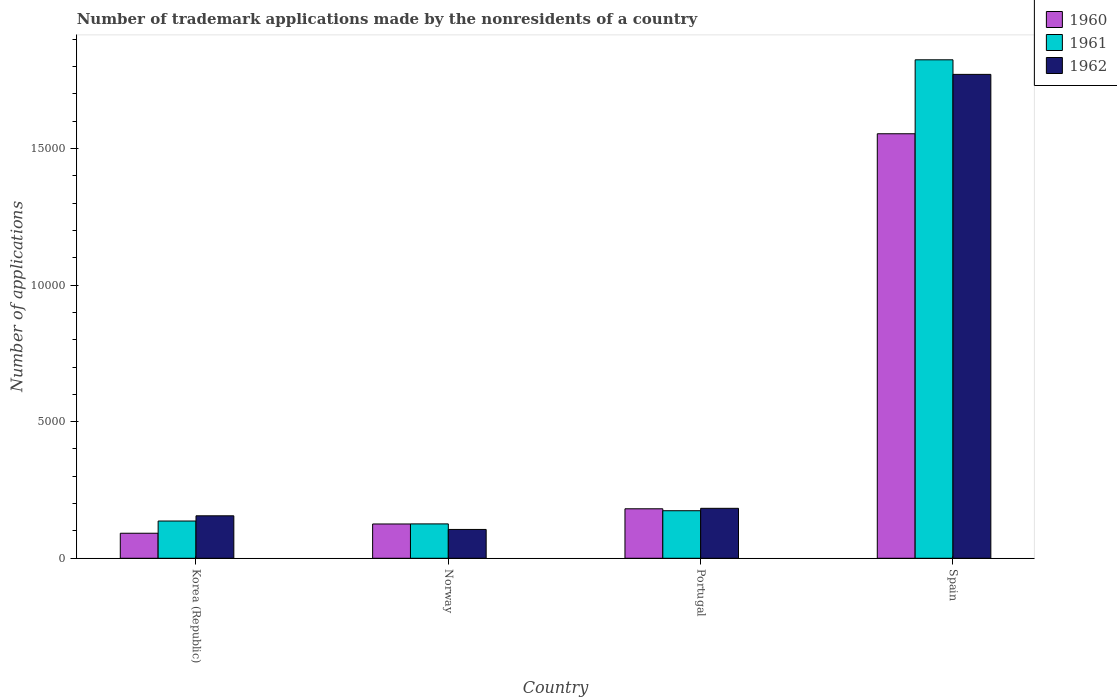How many different coloured bars are there?
Make the answer very short. 3. Are the number of bars per tick equal to the number of legend labels?
Ensure brevity in your answer.  Yes. In how many cases, is the number of bars for a given country not equal to the number of legend labels?
Provide a succinct answer. 0. What is the number of trademark applications made by the nonresidents in 1961 in Spain?
Your answer should be compact. 1.82e+04. Across all countries, what is the maximum number of trademark applications made by the nonresidents in 1960?
Your response must be concise. 1.55e+04. Across all countries, what is the minimum number of trademark applications made by the nonresidents in 1962?
Provide a short and direct response. 1055. In which country was the number of trademark applications made by the nonresidents in 1961 maximum?
Give a very brief answer. Spain. What is the total number of trademark applications made by the nonresidents in 1962 in the graph?
Your response must be concise. 2.21e+04. What is the difference between the number of trademark applications made by the nonresidents in 1962 in Korea (Republic) and that in Norway?
Ensure brevity in your answer.  499. What is the difference between the number of trademark applications made by the nonresidents in 1960 in Portugal and the number of trademark applications made by the nonresidents in 1962 in Norway?
Offer a terse response. 756. What is the average number of trademark applications made by the nonresidents in 1962 per country?
Your answer should be very brief. 5536.75. What is the difference between the number of trademark applications made by the nonresidents of/in 1961 and number of trademark applications made by the nonresidents of/in 1960 in Korea (Republic)?
Keep it short and to the point. 447. What is the ratio of the number of trademark applications made by the nonresidents in 1960 in Korea (Republic) to that in Portugal?
Make the answer very short. 0.51. Is the number of trademark applications made by the nonresidents in 1961 in Norway less than that in Portugal?
Provide a succinct answer. Yes. Is the difference between the number of trademark applications made by the nonresidents in 1961 in Portugal and Spain greater than the difference between the number of trademark applications made by the nonresidents in 1960 in Portugal and Spain?
Offer a terse response. No. What is the difference between the highest and the second highest number of trademark applications made by the nonresidents in 1961?
Your answer should be compact. -377. What is the difference between the highest and the lowest number of trademark applications made by the nonresidents in 1962?
Provide a succinct answer. 1.67e+04. What does the 3rd bar from the left in Spain represents?
Ensure brevity in your answer.  1962. Is it the case that in every country, the sum of the number of trademark applications made by the nonresidents in 1960 and number of trademark applications made by the nonresidents in 1962 is greater than the number of trademark applications made by the nonresidents in 1961?
Keep it short and to the point. Yes. How many bars are there?
Make the answer very short. 12. Are all the bars in the graph horizontal?
Ensure brevity in your answer.  No. What is the difference between two consecutive major ticks on the Y-axis?
Your answer should be very brief. 5000. Does the graph contain any zero values?
Ensure brevity in your answer.  No. Does the graph contain grids?
Make the answer very short. No. Where does the legend appear in the graph?
Keep it short and to the point. Top right. How many legend labels are there?
Offer a terse response. 3. What is the title of the graph?
Provide a succinct answer. Number of trademark applications made by the nonresidents of a country. What is the label or title of the Y-axis?
Offer a terse response. Number of applications. What is the Number of applications of 1960 in Korea (Republic)?
Provide a succinct answer. 916. What is the Number of applications in 1961 in Korea (Republic)?
Give a very brief answer. 1363. What is the Number of applications of 1962 in Korea (Republic)?
Your answer should be very brief. 1554. What is the Number of applications of 1960 in Norway?
Your answer should be very brief. 1255. What is the Number of applications in 1961 in Norway?
Ensure brevity in your answer.  1258. What is the Number of applications in 1962 in Norway?
Ensure brevity in your answer.  1055. What is the Number of applications in 1960 in Portugal?
Provide a short and direct response. 1811. What is the Number of applications of 1961 in Portugal?
Make the answer very short. 1740. What is the Number of applications in 1962 in Portugal?
Provide a short and direct response. 1828. What is the Number of applications of 1960 in Spain?
Ensure brevity in your answer.  1.55e+04. What is the Number of applications of 1961 in Spain?
Your answer should be very brief. 1.82e+04. What is the Number of applications of 1962 in Spain?
Your answer should be very brief. 1.77e+04. Across all countries, what is the maximum Number of applications in 1960?
Give a very brief answer. 1.55e+04. Across all countries, what is the maximum Number of applications of 1961?
Your answer should be very brief. 1.82e+04. Across all countries, what is the maximum Number of applications of 1962?
Your answer should be compact. 1.77e+04. Across all countries, what is the minimum Number of applications of 1960?
Ensure brevity in your answer.  916. Across all countries, what is the minimum Number of applications of 1961?
Your answer should be compact. 1258. Across all countries, what is the minimum Number of applications of 1962?
Your answer should be very brief. 1055. What is the total Number of applications of 1960 in the graph?
Keep it short and to the point. 1.95e+04. What is the total Number of applications of 1961 in the graph?
Offer a terse response. 2.26e+04. What is the total Number of applications in 1962 in the graph?
Ensure brevity in your answer.  2.21e+04. What is the difference between the Number of applications of 1960 in Korea (Republic) and that in Norway?
Offer a very short reply. -339. What is the difference between the Number of applications of 1961 in Korea (Republic) and that in Norway?
Give a very brief answer. 105. What is the difference between the Number of applications of 1962 in Korea (Republic) and that in Norway?
Ensure brevity in your answer.  499. What is the difference between the Number of applications in 1960 in Korea (Republic) and that in Portugal?
Provide a succinct answer. -895. What is the difference between the Number of applications of 1961 in Korea (Republic) and that in Portugal?
Offer a terse response. -377. What is the difference between the Number of applications of 1962 in Korea (Republic) and that in Portugal?
Your response must be concise. -274. What is the difference between the Number of applications of 1960 in Korea (Republic) and that in Spain?
Your answer should be very brief. -1.46e+04. What is the difference between the Number of applications of 1961 in Korea (Republic) and that in Spain?
Make the answer very short. -1.69e+04. What is the difference between the Number of applications in 1962 in Korea (Republic) and that in Spain?
Keep it short and to the point. -1.62e+04. What is the difference between the Number of applications in 1960 in Norway and that in Portugal?
Provide a short and direct response. -556. What is the difference between the Number of applications of 1961 in Norway and that in Portugal?
Offer a very short reply. -482. What is the difference between the Number of applications in 1962 in Norway and that in Portugal?
Provide a succinct answer. -773. What is the difference between the Number of applications in 1960 in Norway and that in Spain?
Provide a short and direct response. -1.43e+04. What is the difference between the Number of applications in 1961 in Norway and that in Spain?
Your answer should be compact. -1.70e+04. What is the difference between the Number of applications in 1962 in Norway and that in Spain?
Keep it short and to the point. -1.67e+04. What is the difference between the Number of applications in 1960 in Portugal and that in Spain?
Offer a terse response. -1.37e+04. What is the difference between the Number of applications in 1961 in Portugal and that in Spain?
Ensure brevity in your answer.  -1.65e+04. What is the difference between the Number of applications of 1962 in Portugal and that in Spain?
Your answer should be very brief. -1.59e+04. What is the difference between the Number of applications of 1960 in Korea (Republic) and the Number of applications of 1961 in Norway?
Make the answer very short. -342. What is the difference between the Number of applications in 1960 in Korea (Republic) and the Number of applications in 1962 in Norway?
Offer a terse response. -139. What is the difference between the Number of applications in 1961 in Korea (Republic) and the Number of applications in 1962 in Norway?
Your answer should be compact. 308. What is the difference between the Number of applications in 1960 in Korea (Republic) and the Number of applications in 1961 in Portugal?
Your response must be concise. -824. What is the difference between the Number of applications of 1960 in Korea (Republic) and the Number of applications of 1962 in Portugal?
Ensure brevity in your answer.  -912. What is the difference between the Number of applications of 1961 in Korea (Republic) and the Number of applications of 1962 in Portugal?
Ensure brevity in your answer.  -465. What is the difference between the Number of applications of 1960 in Korea (Republic) and the Number of applications of 1961 in Spain?
Your response must be concise. -1.73e+04. What is the difference between the Number of applications of 1960 in Korea (Republic) and the Number of applications of 1962 in Spain?
Give a very brief answer. -1.68e+04. What is the difference between the Number of applications of 1961 in Korea (Republic) and the Number of applications of 1962 in Spain?
Keep it short and to the point. -1.63e+04. What is the difference between the Number of applications of 1960 in Norway and the Number of applications of 1961 in Portugal?
Your answer should be compact. -485. What is the difference between the Number of applications in 1960 in Norway and the Number of applications in 1962 in Portugal?
Provide a succinct answer. -573. What is the difference between the Number of applications in 1961 in Norway and the Number of applications in 1962 in Portugal?
Make the answer very short. -570. What is the difference between the Number of applications of 1960 in Norway and the Number of applications of 1961 in Spain?
Provide a succinct answer. -1.70e+04. What is the difference between the Number of applications of 1960 in Norway and the Number of applications of 1962 in Spain?
Offer a terse response. -1.65e+04. What is the difference between the Number of applications in 1961 in Norway and the Number of applications in 1962 in Spain?
Your answer should be compact. -1.65e+04. What is the difference between the Number of applications of 1960 in Portugal and the Number of applications of 1961 in Spain?
Give a very brief answer. -1.64e+04. What is the difference between the Number of applications of 1960 in Portugal and the Number of applications of 1962 in Spain?
Make the answer very short. -1.59e+04. What is the difference between the Number of applications of 1961 in Portugal and the Number of applications of 1962 in Spain?
Ensure brevity in your answer.  -1.60e+04. What is the average Number of applications in 1960 per country?
Ensure brevity in your answer.  4879.75. What is the average Number of applications of 1961 per country?
Keep it short and to the point. 5651.25. What is the average Number of applications of 1962 per country?
Your response must be concise. 5536.75. What is the difference between the Number of applications in 1960 and Number of applications in 1961 in Korea (Republic)?
Your response must be concise. -447. What is the difference between the Number of applications of 1960 and Number of applications of 1962 in Korea (Republic)?
Give a very brief answer. -638. What is the difference between the Number of applications in 1961 and Number of applications in 1962 in Korea (Republic)?
Your answer should be very brief. -191. What is the difference between the Number of applications of 1960 and Number of applications of 1961 in Norway?
Provide a succinct answer. -3. What is the difference between the Number of applications of 1960 and Number of applications of 1962 in Norway?
Your response must be concise. 200. What is the difference between the Number of applications in 1961 and Number of applications in 1962 in Norway?
Your response must be concise. 203. What is the difference between the Number of applications of 1960 and Number of applications of 1961 in Portugal?
Ensure brevity in your answer.  71. What is the difference between the Number of applications of 1960 and Number of applications of 1962 in Portugal?
Ensure brevity in your answer.  -17. What is the difference between the Number of applications of 1961 and Number of applications of 1962 in Portugal?
Your answer should be very brief. -88. What is the difference between the Number of applications in 1960 and Number of applications in 1961 in Spain?
Provide a succinct answer. -2707. What is the difference between the Number of applications in 1960 and Number of applications in 1962 in Spain?
Your response must be concise. -2173. What is the difference between the Number of applications of 1961 and Number of applications of 1962 in Spain?
Offer a terse response. 534. What is the ratio of the Number of applications in 1960 in Korea (Republic) to that in Norway?
Your answer should be compact. 0.73. What is the ratio of the Number of applications in 1961 in Korea (Republic) to that in Norway?
Provide a succinct answer. 1.08. What is the ratio of the Number of applications of 1962 in Korea (Republic) to that in Norway?
Your response must be concise. 1.47. What is the ratio of the Number of applications in 1960 in Korea (Republic) to that in Portugal?
Offer a terse response. 0.51. What is the ratio of the Number of applications of 1961 in Korea (Republic) to that in Portugal?
Offer a terse response. 0.78. What is the ratio of the Number of applications in 1962 in Korea (Republic) to that in Portugal?
Ensure brevity in your answer.  0.85. What is the ratio of the Number of applications of 1960 in Korea (Republic) to that in Spain?
Offer a terse response. 0.06. What is the ratio of the Number of applications in 1961 in Korea (Republic) to that in Spain?
Your answer should be compact. 0.07. What is the ratio of the Number of applications of 1962 in Korea (Republic) to that in Spain?
Give a very brief answer. 0.09. What is the ratio of the Number of applications in 1960 in Norway to that in Portugal?
Offer a terse response. 0.69. What is the ratio of the Number of applications of 1961 in Norway to that in Portugal?
Offer a terse response. 0.72. What is the ratio of the Number of applications of 1962 in Norway to that in Portugal?
Keep it short and to the point. 0.58. What is the ratio of the Number of applications in 1960 in Norway to that in Spain?
Offer a very short reply. 0.08. What is the ratio of the Number of applications in 1961 in Norway to that in Spain?
Your response must be concise. 0.07. What is the ratio of the Number of applications of 1962 in Norway to that in Spain?
Keep it short and to the point. 0.06. What is the ratio of the Number of applications in 1960 in Portugal to that in Spain?
Provide a short and direct response. 0.12. What is the ratio of the Number of applications in 1961 in Portugal to that in Spain?
Provide a succinct answer. 0.1. What is the ratio of the Number of applications of 1962 in Portugal to that in Spain?
Offer a terse response. 0.1. What is the difference between the highest and the second highest Number of applications of 1960?
Provide a short and direct response. 1.37e+04. What is the difference between the highest and the second highest Number of applications in 1961?
Provide a short and direct response. 1.65e+04. What is the difference between the highest and the second highest Number of applications of 1962?
Make the answer very short. 1.59e+04. What is the difference between the highest and the lowest Number of applications of 1960?
Provide a short and direct response. 1.46e+04. What is the difference between the highest and the lowest Number of applications in 1961?
Offer a very short reply. 1.70e+04. What is the difference between the highest and the lowest Number of applications in 1962?
Your answer should be very brief. 1.67e+04. 